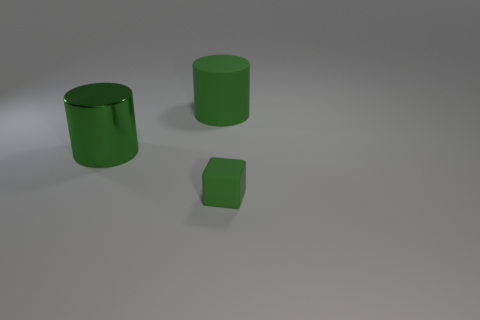What color is the rubber cylinder?
Your response must be concise. Green. Is there a blue sphere that has the same material as the small block?
Provide a short and direct response. No. Are there any large green shiny objects behind the tiny rubber thing that is right of the matte thing behind the tiny rubber object?
Offer a terse response. Yes. There is a tiny matte object; are there any tiny blocks behind it?
Your answer should be compact. No. Are there any large cylinders that have the same color as the small rubber block?
Ensure brevity in your answer.  Yes. How many big objects are either blue blocks or green cylinders?
Offer a terse response. 2. Is the material of the cylinder that is behind the large green metallic thing the same as the block?
Provide a succinct answer. Yes. What is the shape of the green object left of the rubber object to the left of the green matte thing that is in front of the rubber cylinder?
Make the answer very short. Cylinder. How many blue things are either cylinders or big metallic things?
Your answer should be compact. 0. Are there the same number of cylinders that are in front of the large matte cylinder and large metal objects that are left of the block?
Provide a succinct answer. Yes. 